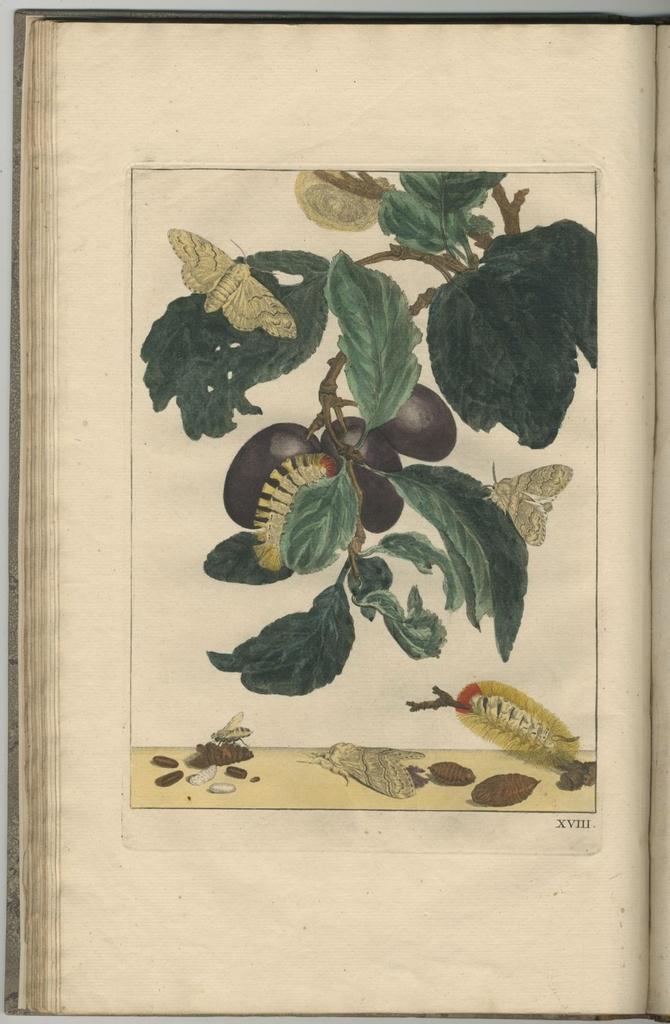Please provide a concise description of this image. In this image there is an open book. In the paper of a book there is a sketch of a plant with leaves and fruits, below that there is an insect and few other things. 